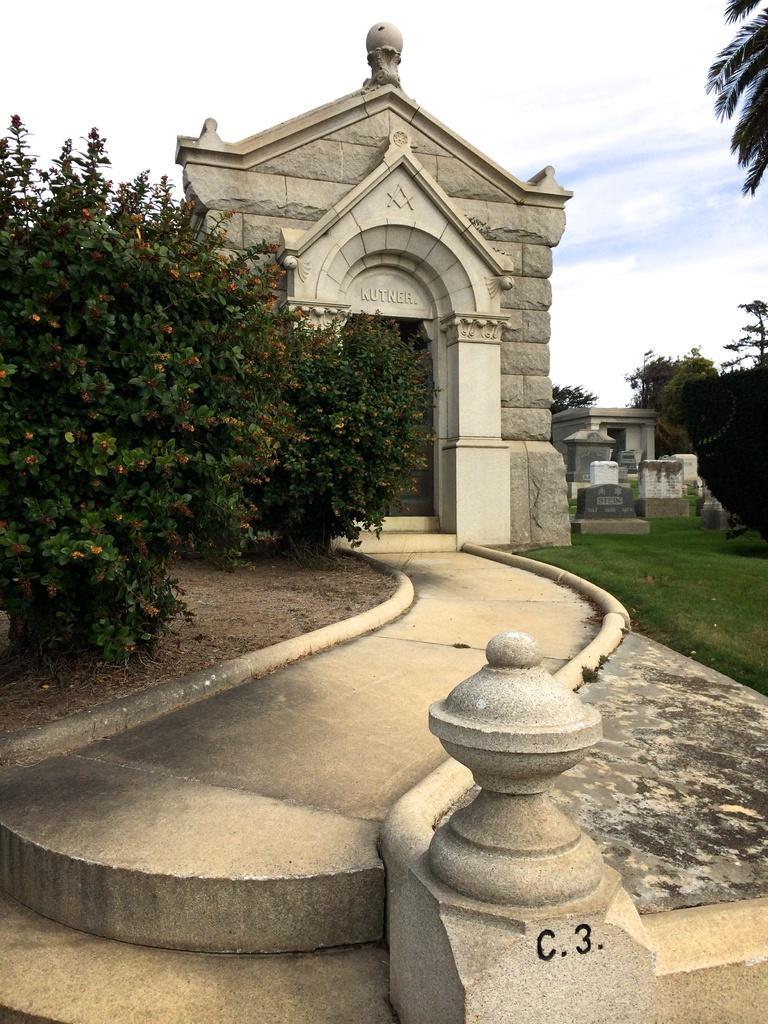Please provide a concise description of this image. In the picture we can see walkway, there is an arch, there is grass and in the background of the picture there are some trees, stones. 